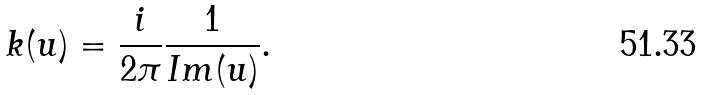<formula> <loc_0><loc_0><loc_500><loc_500>k ( u ) = \frac { i } { 2 \pi } \frac { 1 } { I m ( u ) } .</formula> 